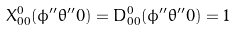<formula> <loc_0><loc_0><loc_500><loc_500>X ^ { 0 } _ { 0 0 } ( \phi ^ { \prime \prime } \theta ^ { \prime \prime } 0 ) = D ^ { 0 } _ { 0 0 } ( \phi ^ { \prime \prime } \theta ^ { \prime \prime } 0 ) = 1</formula> 